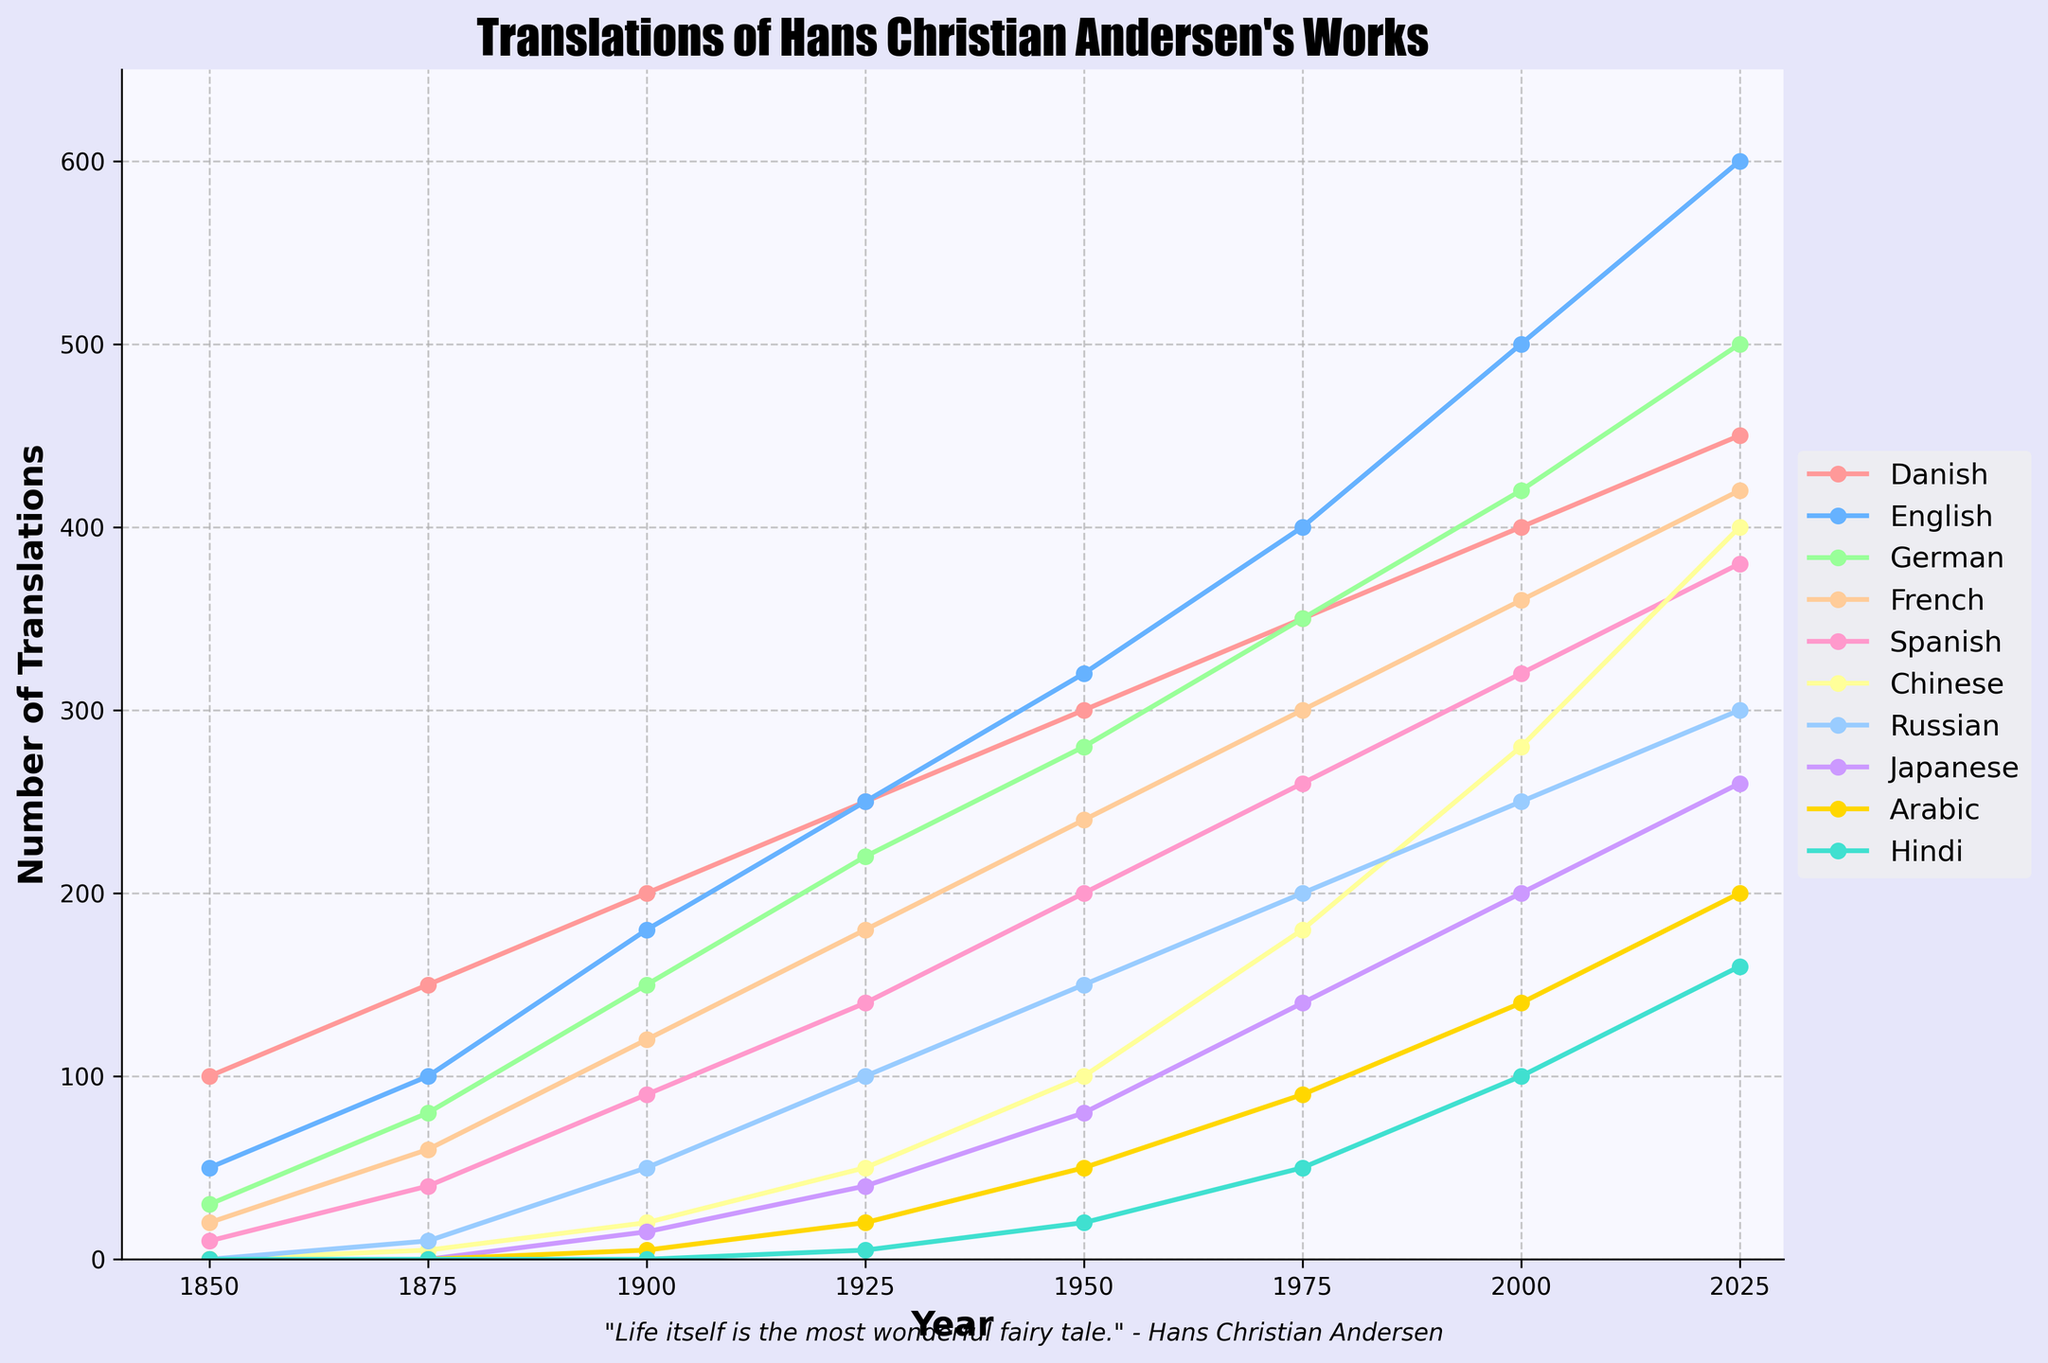Which language had the most translations of Hans Christian Andersen's works in 2025? First, locate the year 2025 on the x-axis. Then, observe the height of each line representing different languages. The line for English is highest in 2025. So, English had the most translations in 2025.
Answer: English How many more translations were there in Spanish compared to French in 1950? Locate the year 1950 on the x-axis and compare the values for Spanish and French. Spanish had 200 translations and French had 240 translations. Subtract the two values: 240 - 200 = 40.
Answer: 40 What is the total number of translations in Japanese from 1875 to 2000? Find the points corresponding to Japanese for 1875, 1900, 1925, 1950, 1975, and 2000. Sum these values: 0 + 15 + 40 + 80 + 140 + 200 = 475.
Answer: 475 Which languages showed a consistent increase in translations over every observed time period? Examine the lines for each language. Only English and Chinese consistently increase in the number of translations from each time period to the next.
Answer: English and Chinese In which year did Russian surpass Chinese in the number of translations? Track the lines corresponding to Russian and Chinese. Russian surpasses Chinese for the first time between 1950 and 1975.
Answer: 1975 How much did the number of Danish translations increase from 1850 to 2025? Locate the values for Danish for the years 1850 and 2025. Danish had 100 translations in 1850 and 450 in 2025. Subtract the two values: 450 - 100 = 350.
Answer: 350 Compare the number of translations in Arabic in 1925 and 2000. How many times did it increase? Locate the values of Arabic translations in 1925 and 2000. Arabic had 20 translations in 1925 and 140 translations in 2000. Divide the values: 140 / 20 = 7.
Answer: 7 What was the average number of translations in Hindi across all years? Locate the values for Hindi across all years: 0, 0, 5, 20, 50, 100, 160. Sum these values: 0 + 0 + 5 + 20 + 50 + 100 + 160 = 335. Divide by the number of data points (7): 335 / 7 ≈ 47.86.
Answer: 47.86 